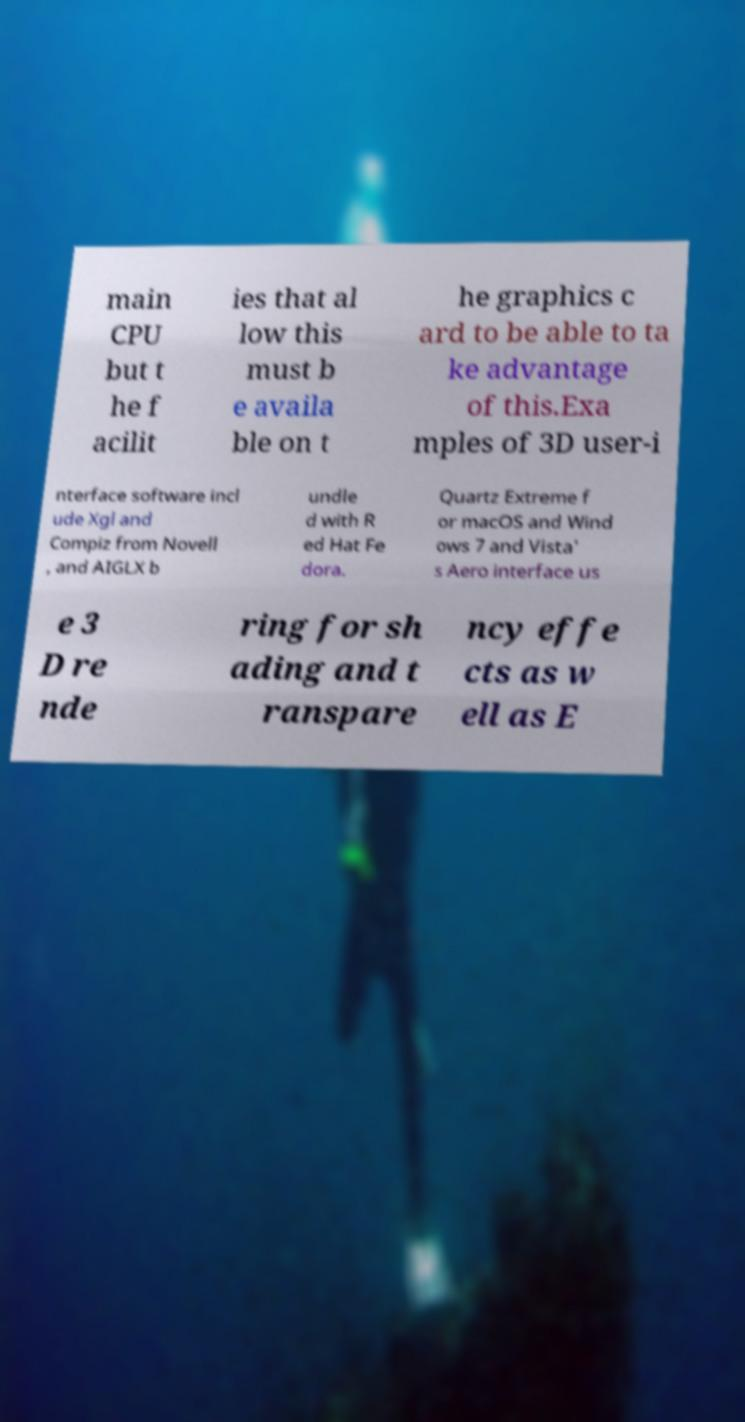Could you extract and type out the text from this image? main CPU but t he f acilit ies that al low this must b e availa ble on t he graphics c ard to be able to ta ke advantage of this.Exa mples of 3D user-i nterface software incl ude Xgl and Compiz from Novell , and AIGLX b undle d with R ed Hat Fe dora. Quartz Extreme f or macOS and Wind ows 7 and Vista' s Aero interface us e 3 D re nde ring for sh ading and t ranspare ncy effe cts as w ell as E 